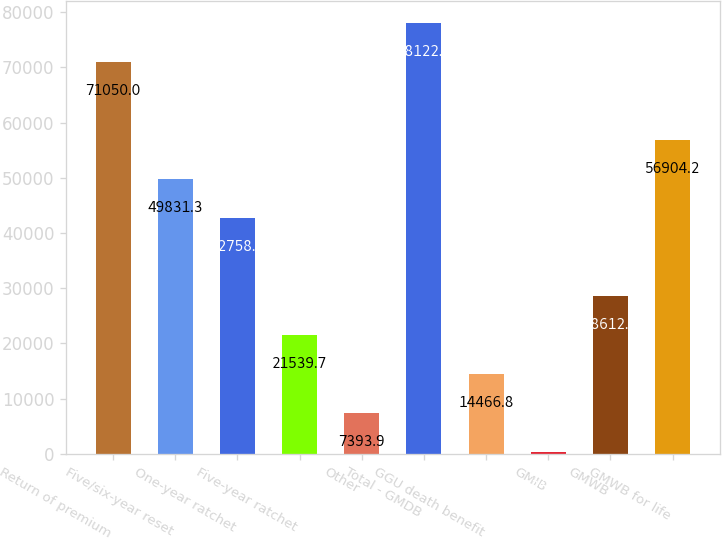Convert chart. <chart><loc_0><loc_0><loc_500><loc_500><bar_chart><fcel>Return of premium<fcel>Five/six-year reset<fcel>One-year ratchet<fcel>Five-year ratchet<fcel>Other<fcel>Total - GMDB<fcel>GGU death benefit<fcel>GMIB<fcel>GMWB<fcel>GMWB for life<nl><fcel>71050<fcel>49831.3<fcel>42758.4<fcel>21539.7<fcel>7393.9<fcel>78122.9<fcel>14466.8<fcel>321<fcel>28612.6<fcel>56904.2<nl></chart> 